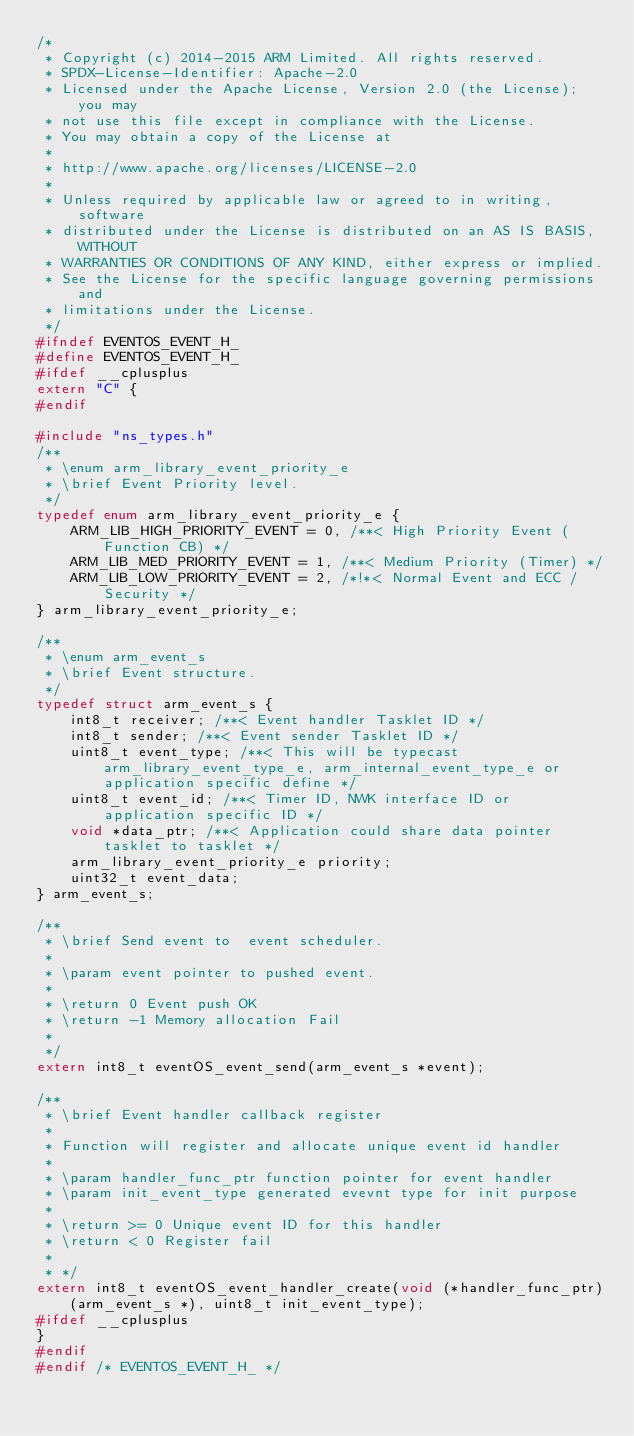<code> <loc_0><loc_0><loc_500><loc_500><_C_>/*
 * Copyright (c) 2014-2015 ARM Limited. All rights reserved.
 * SPDX-License-Identifier: Apache-2.0
 * Licensed under the Apache License, Version 2.0 (the License); you may
 * not use this file except in compliance with the License.
 * You may obtain a copy of the License at
 *
 * http://www.apache.org/licenses/LICENSE-2.0
 *
 * Unless required by applicable law or agreed to in writing, software
 * distributed under the License is distributed on an AS IS BASIS, WITHOUT
 * WARRANTIES OR CONDITIONS OF ANY KIND, either express or implied.
 * See the License for the specific language governing permissions and
 * limitations under the License.
 */
#ifndef EVENTOS_EVENT_H_
#define EVENTOS_EVENT_H_
#ifdef __cplusplus
extern "C" {
#endif

#include "ns_types.h"
/**
 * \enum arm_library_event_priority_e
 * \brief Event Priority level.
 */
typedef enum arm_library_event_priority_e {
    ARM_LIB_HIGH_PRIORITY_EVENT = 0, /**< High Priority Event (Function CB) */
    ARM_LIB_MED_PRIORITY_EVENT = 1, /**< Medium Priority (Timer) */
    ARM_LIB_LOW_PRIORITY_EVENT = 2, /*!*< Normal Event and ECC / Security */
} arm_library_event_priority_e;

/**
 * \enum arm_event_s
 * \brief Event structure.
 */
typedef struct arm_event_s {
    int8_t receiver; /**< Event handler Tasklet ID */
    int8_t sender; /**< Event sender Tasklet ID */
    uint8_t event_type; /**< This will be typecast arm_library_event_type_e, arm_internal_event_type_e or application specific define */
    uint8_t event_id; /**< Timer ID, NWK interface ID or application specific ID */
    void *data_ptr; /**< Application could share data pointer tasklet to tasklet */
    arm_library_event_priority_e priority;
    uint32_t event_data;
} arm_event_s;

/**
 * \brief Send event to  event scheduler.
 *
 * \param event pointer to pushed event.
 *
 * \return 0 Event push OK
 * \return -1 Memory allocation Fail
 *
 */
extern int8_t eventOS_event_send(arm_event_s *event);

/**
 * \brief Event handler callback register
 *
 * Function will register and allocate unique event id handler
 *
 * \param handler_func_ptr function pointer for event handler
 * \param init_event_type generated evevnt type for init purpose
 *
 * \return >= 0 Unique event ID for this handler
 * \return < 0 Register fail
 *
 * */
extern int8_t eventOS_event_handler_create(void (*handler_func_ptr)(arm_event_s *), uint8_t init_event_type);
#ifdef __cplusplus
}
#endif
#endif /* EVENTOS_EVENT_H_ */
</code> 